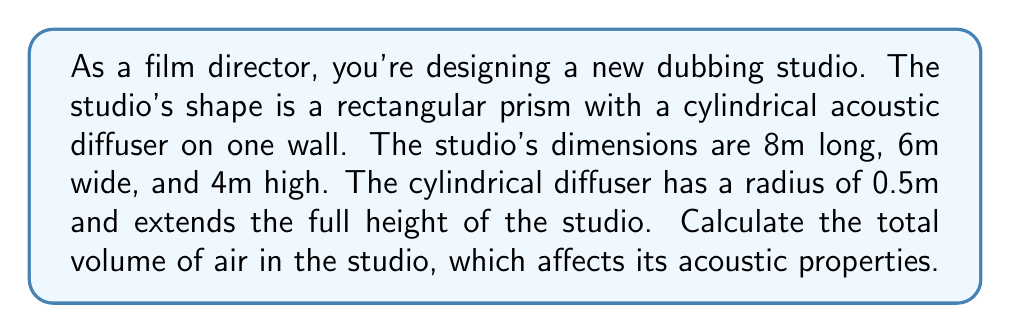Provide a solution to this math problem. Let's approach this step-by-step:

1) First, calculate the volume of the rectangular prism (studio):
   $$V_{prism} = l \times w \times h = 8 \times 6 \times 4 = 192 \text{ m}^3$$

2) Next, calculate the volume of the cylindrical diffuser:
   $$V_{cylinder} = \pi r^2 h = \pi \times 0.5^2 \times 4 = \pi \text{ m}^3$$

3) The total volume of air in the studio is the difference between these two volumes:
   $$V_{total} = V_{prism} - V_{cylinder} = 192 - \pi \text{ m}^3$$

4) Simplify:
   $$V_{total} = (192 - \pi) \text{ m}^3 \approx 188.86 \text{ m}^3$$

[asy]
import three;

size(200);
currentprojection=perspective(6,3,2);

// Draw the room
draw(box((0,0,0),(8,6,4)));

// Draw the cylinder
draw(shift(8,3,0)*cylinder((0,0,0),(0,0,4),0.5));

// Labels
label("8m", (4,6,0), S);
label("6m", (8,3,0), E);
label("4m", (8,6,2), NE);
label("r=0.5m", (8,3,2), W);
[/asy]
Answer: $(192 - \pi) \text{ m}^3$ 